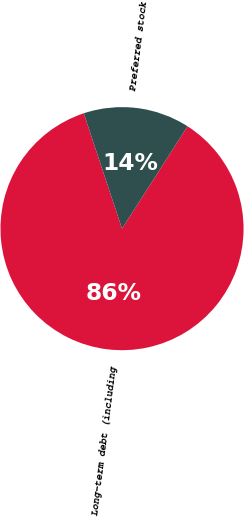<chart> <loc_0><loc_0><loc_500><loc_500><pie_chart><fcel>Long-term debt (including<fcel>Preferred stock<nl><fcel>85.84%<fcel>14.16%<nl></chart> 